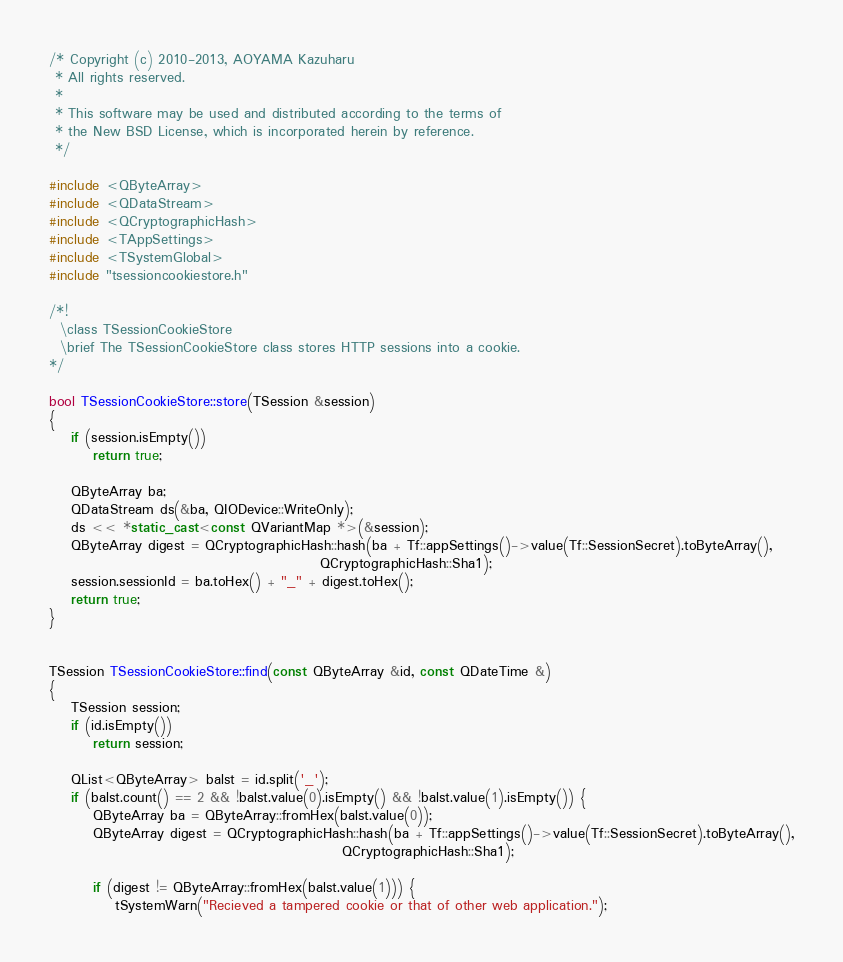<code> <loc_0><loc_0><loc_500><loc_500><_C++_>/* Copyright (c) 2010-2013, AOYAMA Kazuharu
 * All rights reserved.
 *
 * This software may be used and distributed according to the terms of
 * the New BSD License, which is incorporated herein by reference.
 */

#include <QByteArray>
#include <QDataStream>
#include <QCryptographicHash>
#include <TAppSettings>
#include <TSystemGlobal>
#include "tsessioncookiestore.h"

/*!
  \class TSessionCookieStore
  \brief The TSessionCookieStore class stores HTTP sessions into a cookie.
*/

bool TSessionCookieStore::store(TSession &session)
{
    if (session.isEmpty())
        return true;

    QByteArray ba;
    QDataStream ds(&ba, QIODevice::WriteOnly);
    ds << *static_cast<const QVariantMap *>(&session);
    QByteArray digest = QCryptographicHash::hash(ba + Tf::appSettings()->value(Tf::SessionSecret).toByteArray(),
                                                 QCryptographicHash::Sha1);
    session.sessionId = ba.toHex() + "_" + digest.toHex();
    return true;
}


TSession TSessionCookieStore::find(const QByteArray &id, const QDateTime &)
{
    TSession session;
    if (id.isEmpty())
        return session;

    QList<QByteArray> balst = id.split('_');
    if (balst.count() == 2 && !balst.value(0).isEmpty() && !balst.value(1).isEmpty()) {
        QByteArray ba = QByteArray::fromHex(balst.value(0));
        QByteArray digest = QCryptographicHash::hash(ba + Tf::appSettings()->value(Tf::SessionSecret).toByteArray(),
                                                     QCryptographicHash::Sha1);

        if (digest != QByteArray::fromHex(balst.value(1))) {
            tSystemWarn("Recieved a tampered cookie or that of other web application.");</code> 